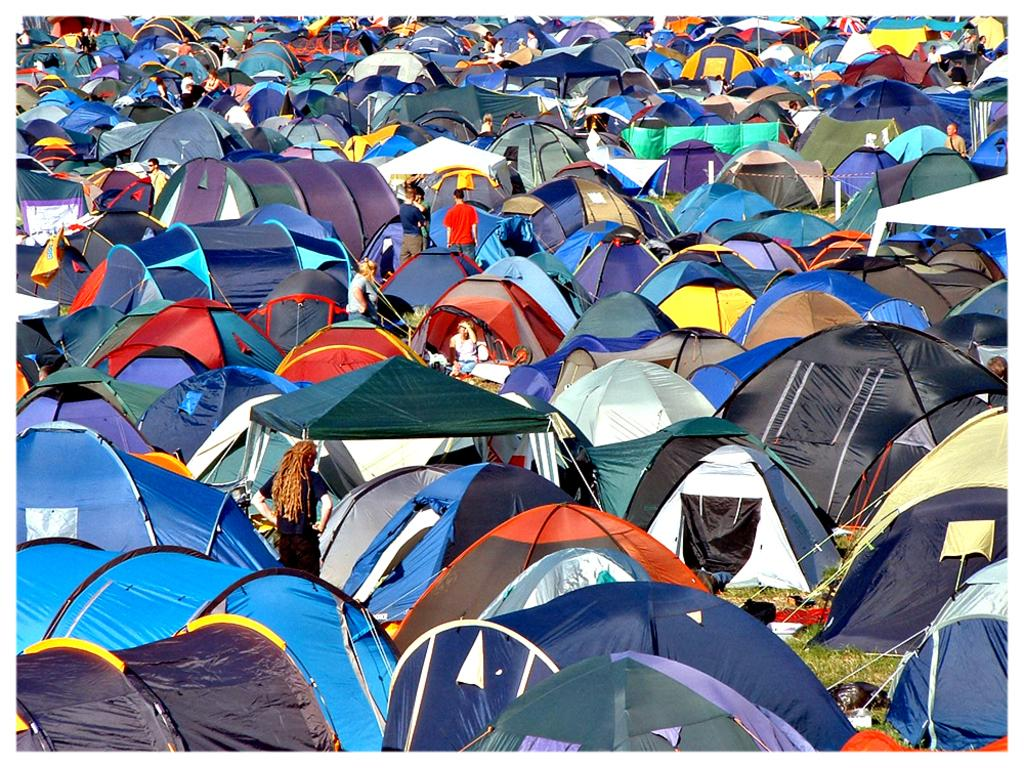What type of structures are set up on the grass in the image? There are tents on the grass in the image. What can be seen in the center of the image? There are people standing in the center of the image. What is the tendency of the wire to affect the people standing in the image? There is no wire present in the image, so it cannot affect the people standing in the image. 